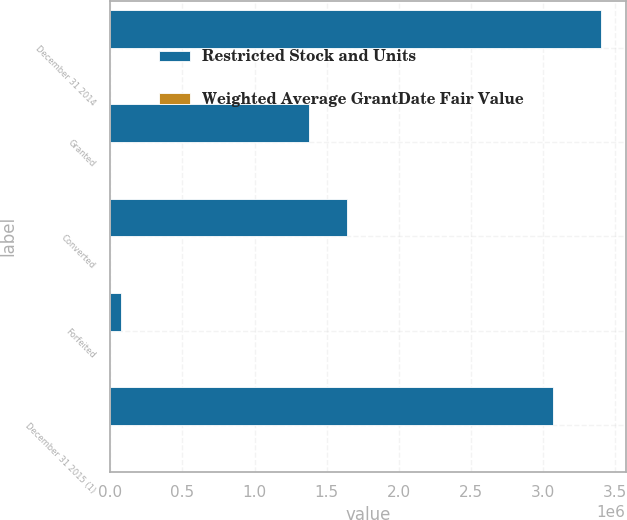<chart> <loc_0><loc_0><loc_500><loc_500><stacked_bar_chart><ecel><fcel>December 31 2014<fcel>Granted<fcel>Converted<fcel>Forfeited<fcel>December 31 2015 (1)<nl><fcel>Restricted Stock and Units<fcel>3.40191e+06<fcel>1.37726e+06<fcel>1.63908e+06<fcel>72357<fcel>3.06774e+06<nl><fcel>Weighted Average GrantDate Fair Value<fcel>257.01<fcel>343.49<fcel>231.26<fcel>306.41<fcel>308.42<nl></chart> 